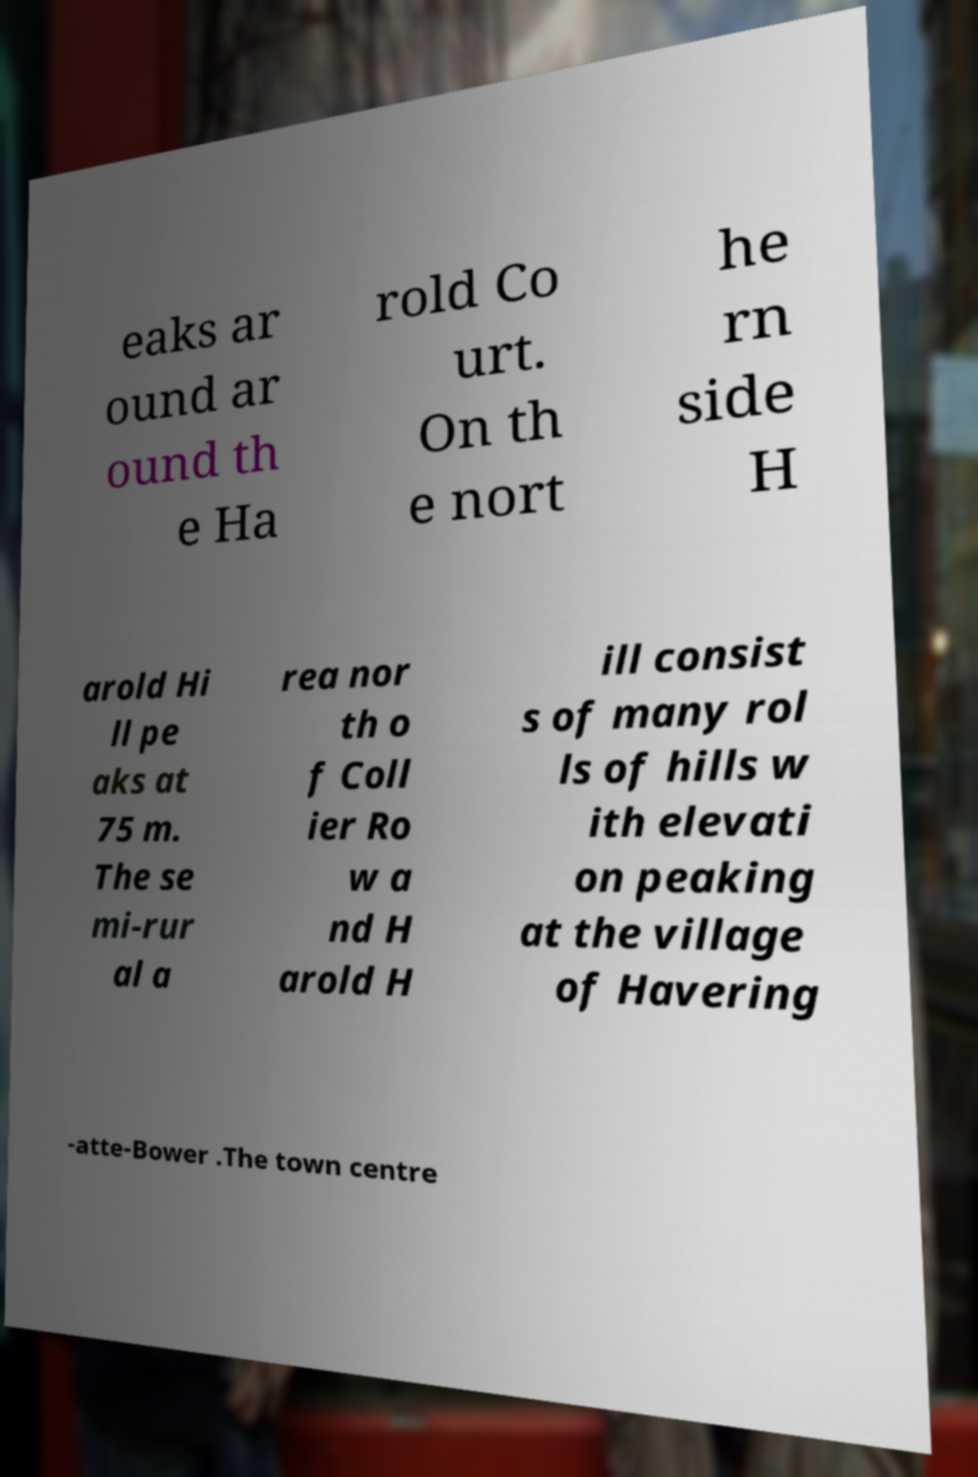I need the written content from this picture converted into text. Can you do that? eaks ar ound ar ound th e Ha rold Co urt. On th e nort he rn side H arold Hi ll pe aks at 75 m. The se mi-rur al a rea nor th o f Coll ier Ro w a nd H arold H ill consist s of many rol ls of hills w ith elevati on peaking at the village of Havering -atte-Bower .The town centre 